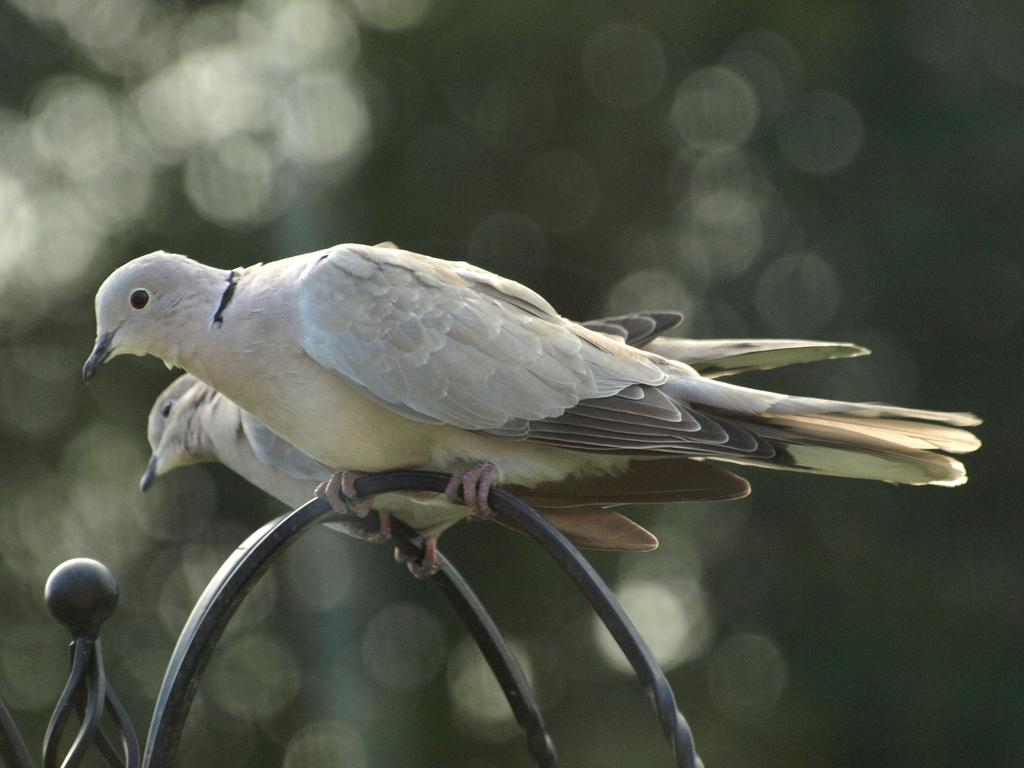What type of animals are present in the image? There are birds in the image. Where are the birds located? The birds are on a metal rod. What colors can be seen on the birds? The birds have white, black, and light green coloring. What type of sheet is being used to cover the mailbox in the image? There is no mailbox or sheet present in the image; it features birds on a metal rod. 